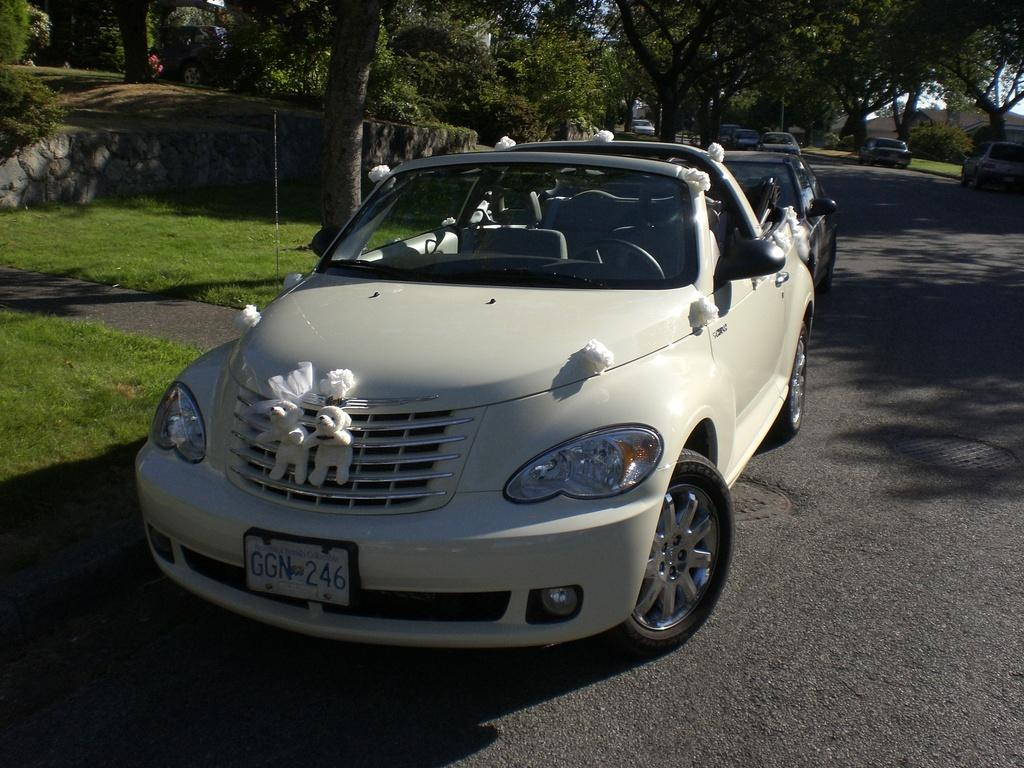What is happening on the road in the image? There are vehicles on the road in the image. What type of vegetation can be seen in the image? There is grass visible in the image, and there are also trees. What is visible in the background of the image? The sky is visible in the background of the image. What type of clover is growing on the road in the image? There is no clover visible in the image; the vegetation consists of grass and trees. 